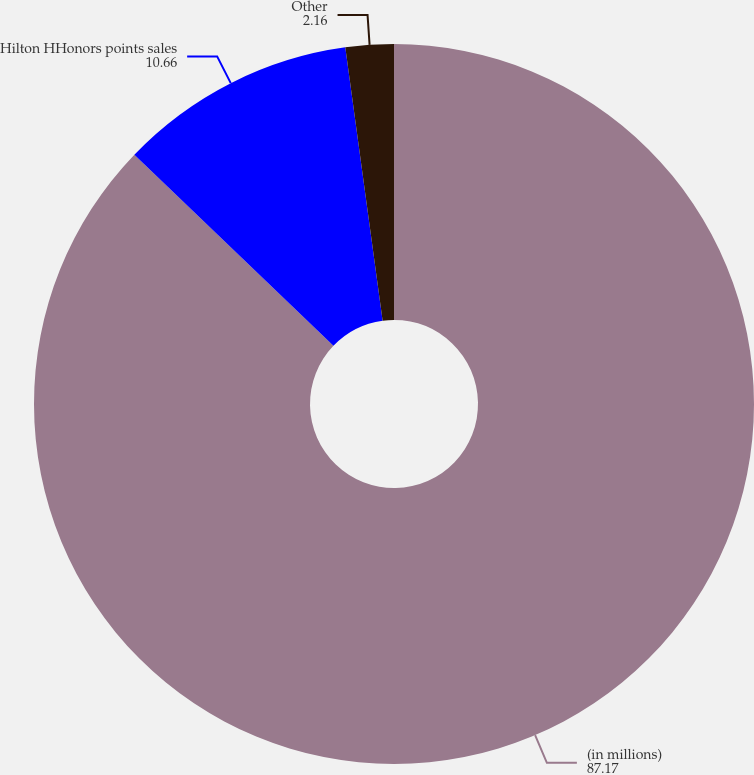<chart> <loc_0><loc_0><loc_500><loc_500><pie_chart><fcel>(in millions)<fcel>Hilton HHonors points sales<fcel>Other<nl><fcel>87.17%<fcel>10.66%<fcel>2.16%<nl></chart> 